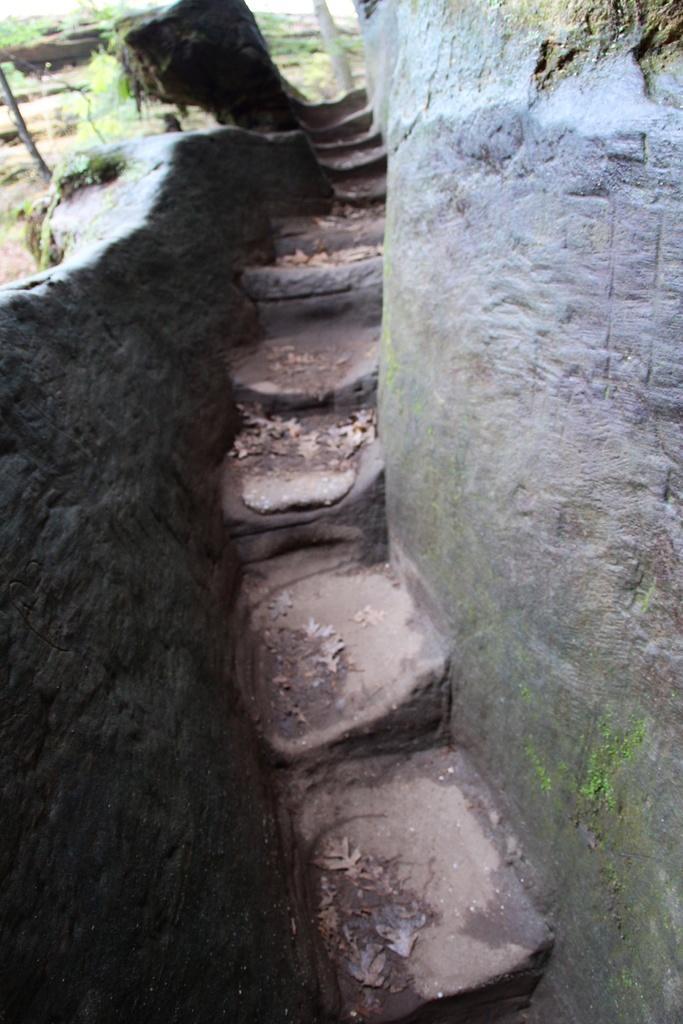Please provide a concise description of this image. In the center of the image we can see the stairs. On the left and on the right we can see the wall. In the background there is grass. 